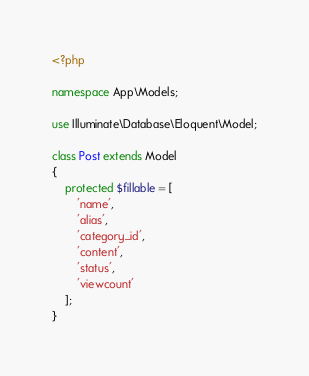Convert code to text. <code><loc_0><loc_0><loc_500><loc_500><_PHP_><?php

namespace App\Models;

use Illuminate\Database\Eloquent\Model;

class Post extends Model
{
    protected $fillable = [
        'name', 
        'alias', 
        'category_id',
        'content', 
        'status', 
        'viewcount'
    ];
}
</code> 